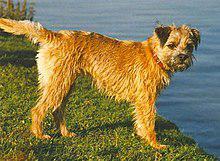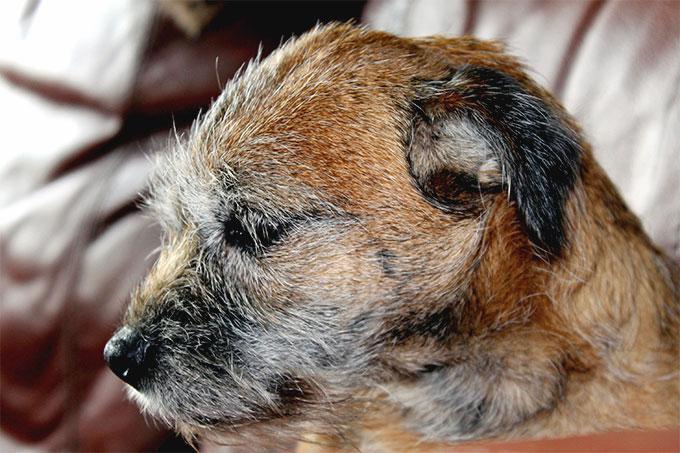The first image is the image on the left, the second image is the image on the right. Evaluate the accuracy of this statement regarding the images: "One of the dogs is facing directly toward the left.". Is it true? Answer yes or no. Yes. 